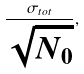Convert formula to latex. <formula><loc_0><loc_0><loc_500><loc_500>\frac { \sigma _ { t o t } } { \sqrt { N _ { 0 } } } ,</formula> 